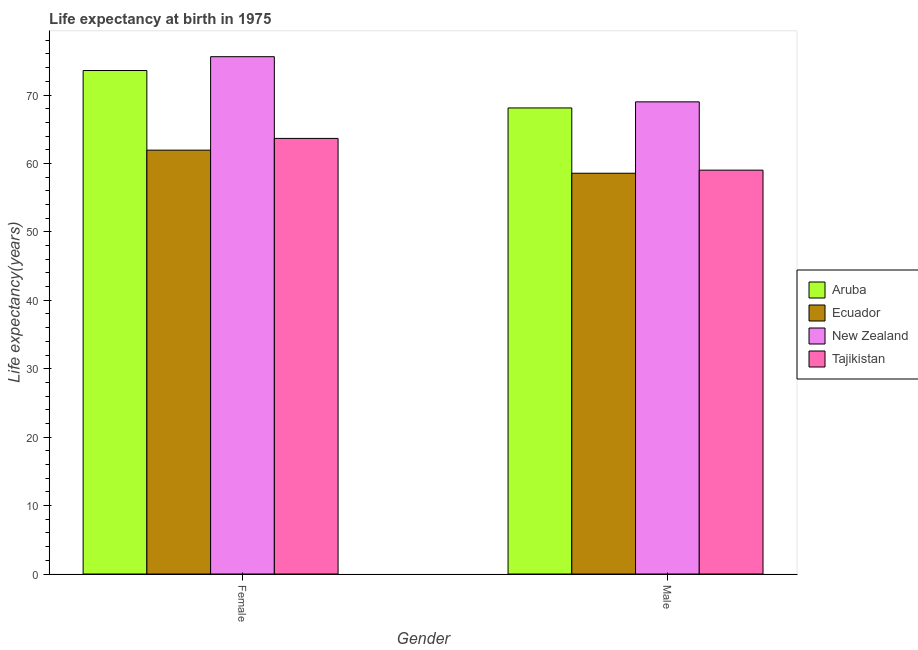How many different coloured bars are there?
Keep it short and to the point. 4. How many bars are there on the 1st tick from the left?
Your response must be concise. 4. What is the label of the 2nd group of bars from the left?
Make the answer very short. Male. Across all countries, what is the maximum life expectancy(male)?
Ensure brevity in your answer.  69. Across all countries, what is the minimum life expectancy(female)?
Offer a terse response. 61.94. In which country was the life expectancy(male) maximum?
Keep it short and to the point. New Zealand. In which country was the life expectancy(female) minimum?
Your response must be concise. Ecuador. What is the total life expectancy(male) in the graph?
Ensure brevity in your answer.  254.7. What is the difference between the life expectancy(male) in Tajikistan and that in New Zealand?
Ensure brevity in your answer.  -9.98. What is the difference between the life expectancy(female) in Tajikistan and the life expectancy(male) in Aruba?
Provide a succinct answer. -4.45. What is the average life expectancy(male) per country?
Offer a very short reply. 63.67. What is the difference between the life expectancy(male) and life expectancy(female) in Ecuador?
Give a very brief answer. -3.37. In how many countries, is the life expectancy(male) greater than 30 years?
Ensure brevity in your answer.  4. What is the ratio of the life expectancy(male) in New Zealand to that in Aruba?
Make the answer very short. 1.01. What does the 3rd bar from the left in Female represents?
Offer a terse response. New Zealand. What does the 2nd bar from the right in Female represents?
Offer a terse response. New Zealand. Are all the bars in the graph horizontal?
Your response must be concise. No. Are the values on the major ticks of Y-axis written in scientific E-notation?
Offer a very short reply. No. Does the graph contain any zero values?
Offer a very short reply. No. Does the graph contain grids?
Provide a succinct answer. No. Where does the legend appear in the graph?
Offer a terse response. Center right. How many legend labels are there?
Offer a very short reply. 4. How are the legend labels stacked?
Your answer should be compact. Vertical. What is the title of the graph?
Give a very brief answer. Life expectancy at birth in 1975. What is the label or title of the Y-axis?
Make the answer very short. Life expectancy(years). What is the Life expectancy(years) of Aruba in Female?
Your response must be concise. 73.58. What is the Life expectancy(years) in Ecuador in Female?
Your response must be concise. 61.94. What is the Life expectancy(years) of New Zealand in Female?
Your answer should be very brief. 75.6. What is the Life expectancy(years) in Tajikistan in Female?
Give a very brief answer. 63.66. What is the Life expectancy(years) of Aruba in Male?
Keep it short and to the point. 68.11. What is the Life expectancy(years) in Ecuador in Male?
Ensure brevity in your answer.  58.57. What is the Life expectancy(years) in New Zealand in Male?
Offer a terse response. 69. What is the Life expectancy(years) of Tajikistan in Male?
Your response must be concise. 59.02. Across all Gender, what is the maximum Life expectancy(years) in Aruba?
Offer a very short reply. 73.58. Across all Gender, what is the maximum Life expectancy(years) of Ecuador?
Keep it short and to the point. 61.94. Across all Gender, what is the maximum Life expectancy(years) in New Zealand?
Your response must be concise. 75.6. Across all Gender, what is the maximum Life expectancy(years) of Tajikistan?
Ensure brevity in your answer.  63.66. Across all Gender, what is the minimum Life expectancy(years) of Aruba?
Provide a short and direct response. 68.11. Across all Gender, what is the minimum Life expectancy(years) of Ecuador?
Your answer should be very brief. 58.57. Across all Gender, what is the minimum Life expectancy(years) of New Zealand?
Provide a succinct answer. 69. Across all Gender, what is the minimum Life expectancy(years) in Tajikistan?
Make the answer very short. 59.02. What is the total Life expectancy(years) in Aruba in the graph?
Provide a succinct answer. 141.69. What is the total Life expectancy(years) of Ecuador in the graph?
Your answer should be compact. 120.51. What is the total Life expectancy(years) in New Zealand in the graph?
Your answer should be compact. 144.6. What is the total Life expectancy(years) of Tajikistan in the graph?
Offer a very short reply. 122.67. What is the difference between the Life expectancy(years) in Aruba in Female and that in Male?
Offer a very short reply. 5.47. What is the difference between the Life expectancy(years) in Ecuador in Female and that in Male?
Provide a succinct answer. 3.37. What is the difference between the Life expectancy(years) of New Zealand in Female and that in Male?
Your answer should be very brief. 6.6. What is the difference between the Life expectancy(years) of Tajikistan in Female and that in Male?
Provide a succinct answer. 4.64. What is the difference between the Life expectancy(years) of Aruba in Female and the Life expectancy(years) of Ecuador in Male?
Offer a terse response. 15.01. What is the difference between the Life expectancy(years) of Aruba in Female and the Life expectancy(years) of New Zealand in Male?
Provide a short and direct response. 4.58. What is the difference between the Life expectancy(years) of Aruba in Female and the Life expectancy(years) of Tajikistan in Male?
Your answer should be compact. 14.56. What is the difference between the Life expectancy(years) in Ecuador in Female and the Life expectancy(years) in New Zealand in Male?
Your answer should be very brief. -7.06. What is the difference between the Life expectancy(years) of Ecuador in Female and the Life expectancy(years) of Tajikistan in Male?
Offer a terse response. 2.92. What is the difference between the Life expectancy(years) in New Zealand in Female and the Life expectancy(years) in Tajikistan in Male?
Give a very brief answer. 16.58. What is the average Life expectancy(years) of Aruba per Gender?
Provide a short and direct response. 70.84. What is the average Life expectancy(years) in Ecuador per Gender?
Make the answer very short. 60.25. What is the average Life expectancy(years) in New Zealand per Gender?
Offer a very short reply. 72.3. What is the average Life expectancy(years) of Tajikistan per Gender?
Provide a short and direct response. 61.34. What is the difference between the Life expectancy(years) in Aruba and Life expectancy(years) in Ecuador in Female?
Ensure brevity in your answer.  11.64. What is the difference between the Life expectancy(years) of Aruba and Life expectancy(years) of New Zealand in Female?
Provide a succinct answer. -2.02. What is the difference between the Life expectancy(years) in Aruba and Life expectancy(years) in Tajikistan in Female?
Your response must be concise. 9.92. What is the difference between the Life expectancy(years) in Ecuador and Life expectancy(years) in New Zealand in Female?
Give a very brief answer. -13.66. What is the difference between the Life expectancy(years) in Ecuador and Life expectancy(years) in Tajikistan in Female?
Keep it short and to the point. -1.72. What is the difference between the Life expectancy(years) in New Zealand and Life expectancy(years) in Tajikistan in Female?
Give a very brief answer. 11.94. What is the difference between the Life expectancy(years) in Aruba and Life expectancy(years) in Ecuador in Male?
Offer a terse response. 9.54. What is the difference between the Life expectancy(years) of Aruba and Life expectancy(years) of New Zealand in Male?
Ensure brevity in your answer.  -0.89. What is the difference between the Life expectancy(years) of Aruba and Life expectancy(years) of Tajikistan in Male?
Provide a short and direct response. 9.09. What is the difference between the Life expectancy(years) in Ecuador and Life expectancy(years) in New Zealand in Male?
Keep it short and to the point. -10.43. What is the difference between the Life expectancy(years) in Ecuador and Life expectancy(years) in Tajikistan in Male?
Offer a very short reply. -0.45. What is the difference between the Life expectancy(years) in New Zealand and Life expectancy(years) in Tajikistan in Male?
Your answer should be very brief. 9.98. What is the ratio of the Life expectancy(years) of Aruba in Female to that in Male?
Your answer should be compact. 1.08. What is the ratio of the Life expectancy(years) in Ecuador in Female to that in Male?
Give a very brief answer. 1.06. What is the ratio of the Life expectancy(years) of New Zealand in Female to that in Male?
Make the answer very short. 1.1. What is the ratio of the Life expectancy(years) in Tajikistan in Female to that in Male?
Provide a succinct answer. 1.08. What is the difference between the highest and the second highest Life expectancy(years) in Aruba?
Your answer should be compact. 5.47. What is the difference between the highest and the second highest Life expectancy(years) in Ecuador?
Offer a terse response. 3.37. What is the difference between the highest and the second highest Life expectancy(years) in Tajikistan?
Provide a short and direct response. 4.64. What is the difference between the highest and the lowest Life expectancy(years) in Aruba?
Your response must be concise. 5.47. What is the difference between the highest and the lowest Life expectancy(years) in Ecuador?
Provide a short and direct response. 3.37. What is the difference between the highest and the lowest Life expectancy(years) in Tajikistan?
Provide a succinct answer. 4.64. 